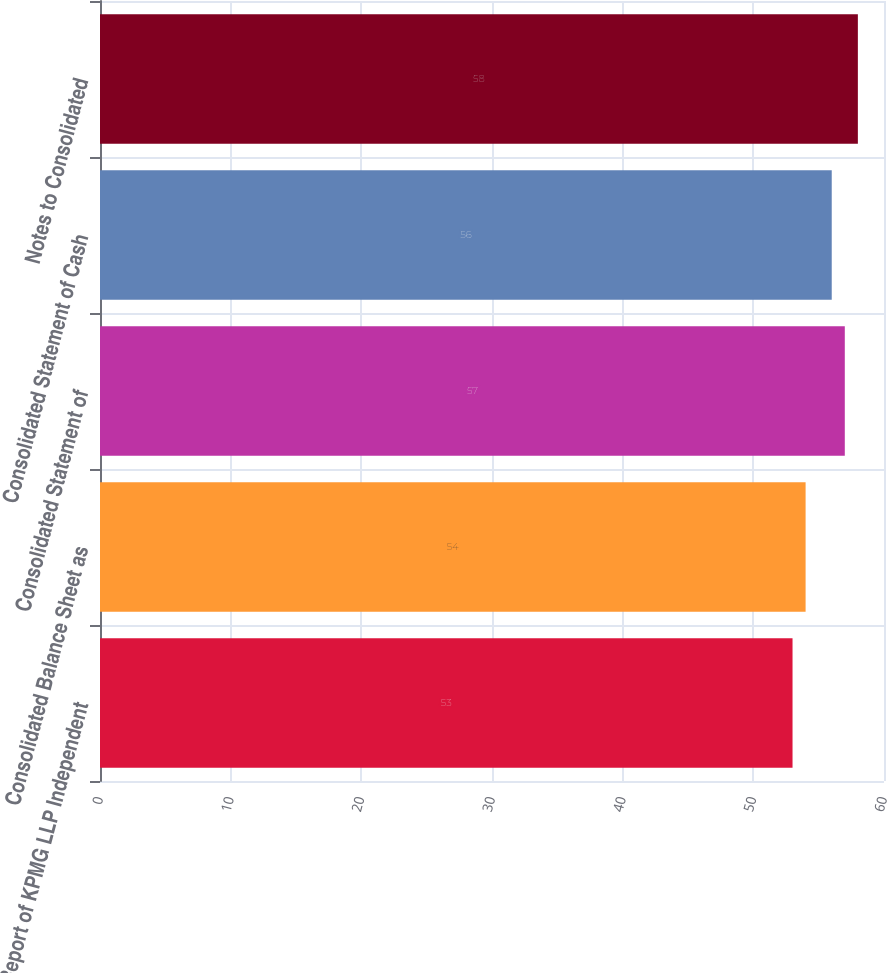<chart> <loc_0><loc_0><loc_500><loc_500><bar_chart><fcel>Report of KPMG LLP Independent<fcel>Consolidated Balance Sheet as<fcel>Consolidated Statement of<fcel>Consolidated Statement of Cash<fcel>Notes to Consolidated<nl><fcel>53<fcel>54<fcel>57<fcel>56<fcel>58<nl></chart> 